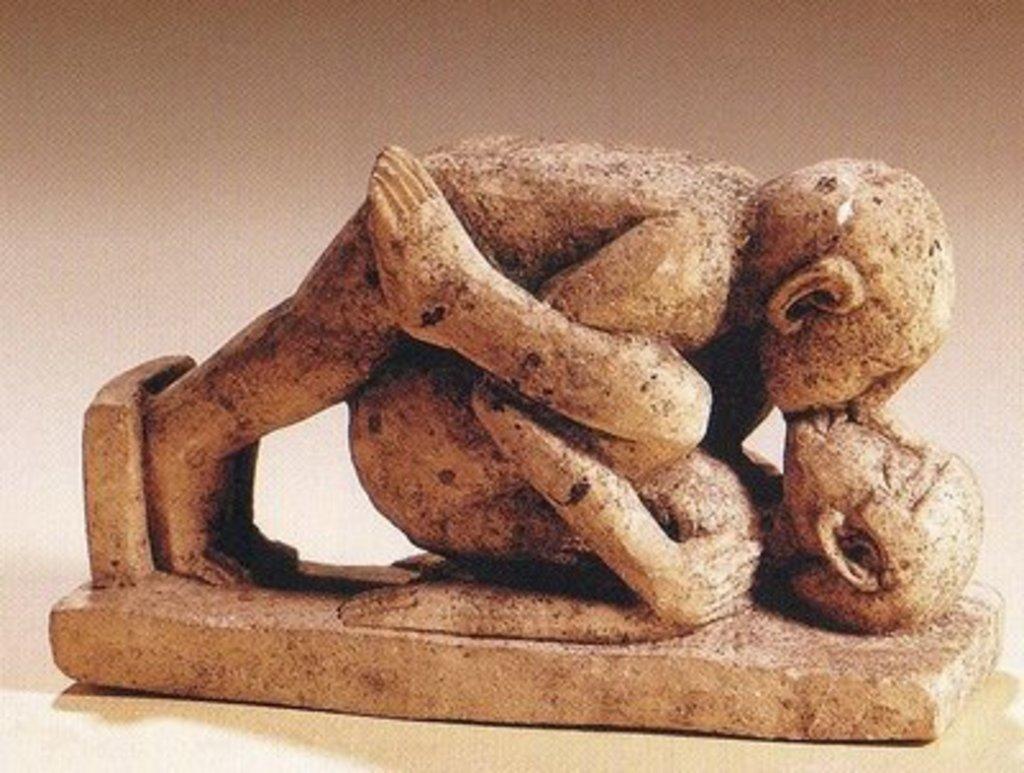How would you summarize this image in a sentence or two? In this picture we can see a statue of persons, who are doing some work. 